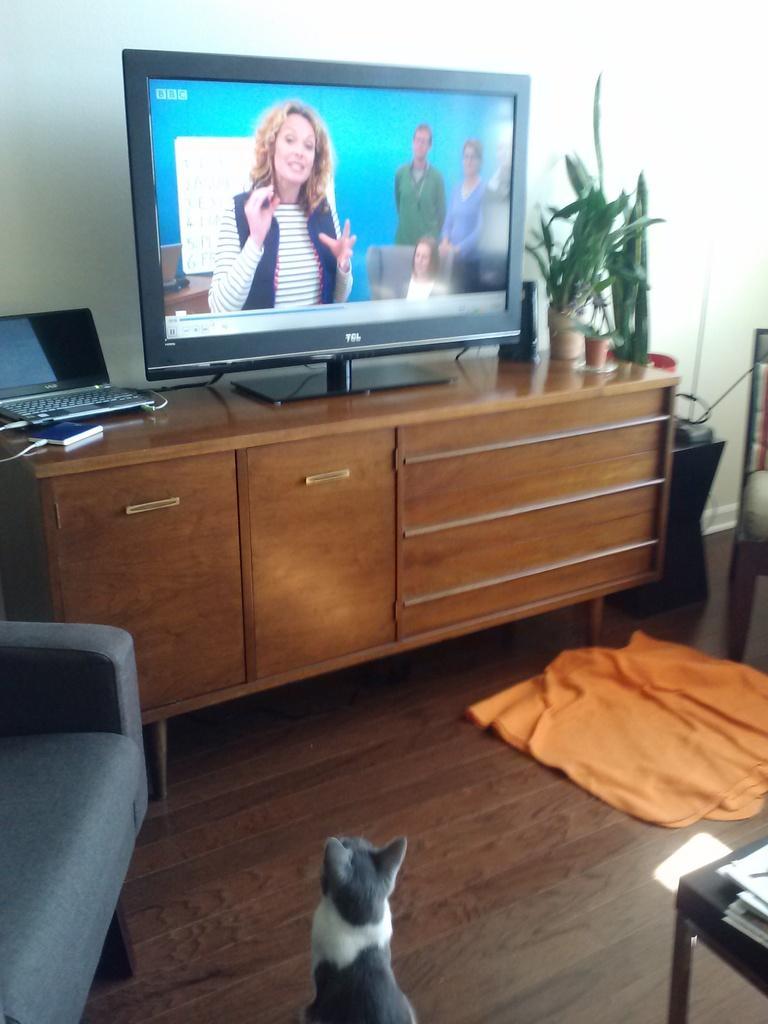Can you describe this image briefly? In the image we can see on the floor there is cat which is looking at the tv which is on table and there is laptop, charger and plants in a pot and there is ash colour chair and on the floor there is orange colour cloth. 